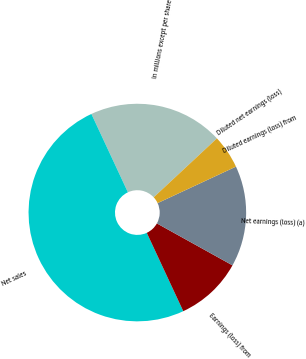Convert chart. <chart><loc_0><loc_0><loc_500><loc_500><pie_chart><fcel>In millions except per share<fcel>Net sales<fcel>Earnings (loss) from<fcel>Net earnings (loss) (a)<fcel>Diluted earnings (loss) from<fcel>Diluted net earnings (loss)<nl><fcel>20.0%<fcel>49.99%<fcel>10.0%<fcel>15.0%<fcel>0.0%<fcel>5.0%<nl></chart> 